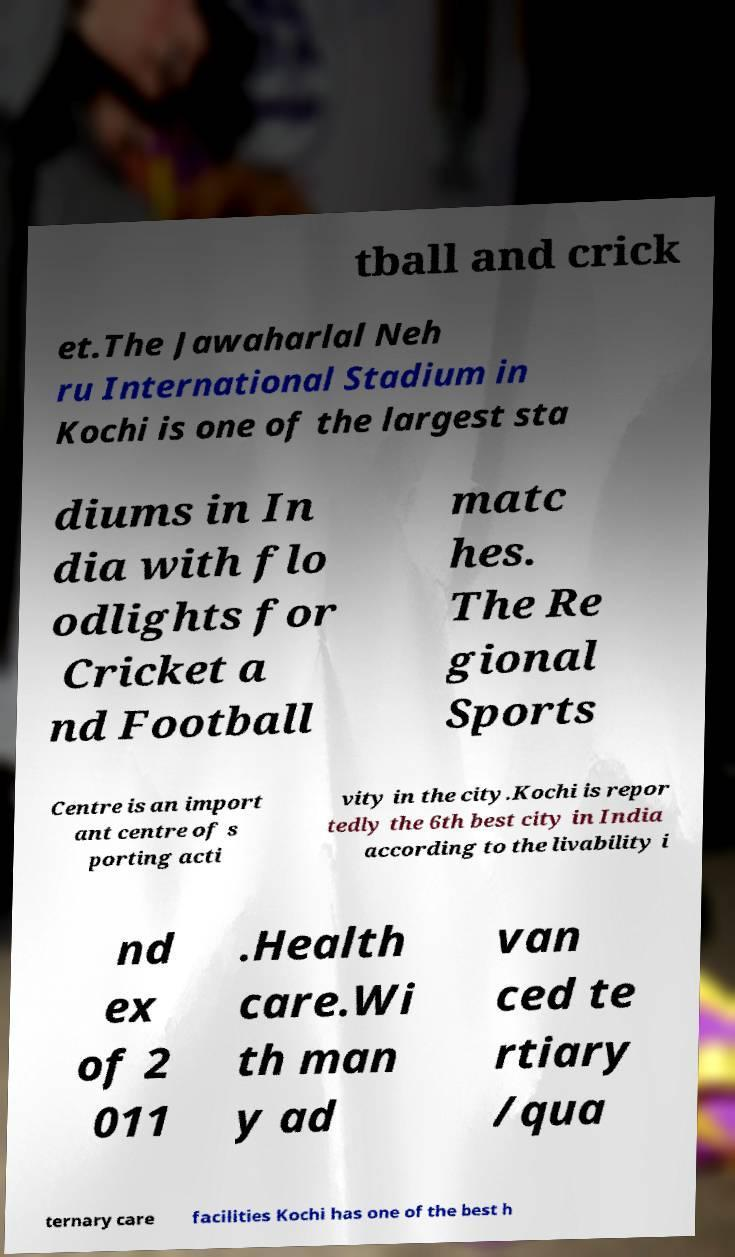Can you accurately transcribe the text from the provided image for me? tball and crick et.The Jawaharlal Neh ru International Stadium in Kochi is one of the largest sta diums in In dia with flo odlights for Cricket a nd Football matc hes. The Re gional Sports Centre is an import ant centre of s porting acti vity in the city.Kochi is repor tedly the 6th best city in India according to the livability i nd ex of 2 011 .Health care.Wi th man y ad van ced te rtiary /qua ternary care facilities Kochi has one of the best h 